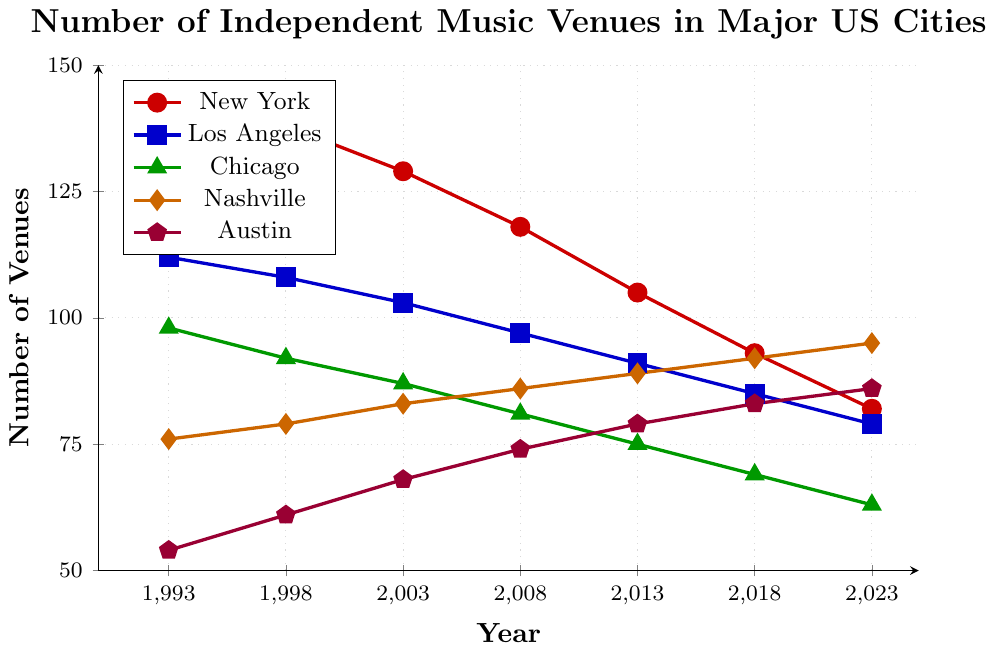How many independent music venues existed in New York in 1993? The figure shows the number of independent music venues for each year for New York. In 1993, New York had 145 venues.
Answer: 145 Which city had the highest number of independent music venues in 2018? The figure provides the number of venues for each city in 2018. Nashville had the highest number with 92 venues.
Answer: Nashville What is the trend of independent music venues in Chicago over the last 30 years? Observing the line representing Chicago on the figure, it shows a downward trend from 98 in 1993 to 63 in 2023.
Answer: Downward trend Between which consecutive years did Austin see the largest increase in the number of independent music venues? Comparing the differences year by year for Austin: 1993-1998: 7, 1998-2003: 7, 2003-2008: 6, 2008-2013: 5, 2013-2018: 4, 2018-2023: 3. The largest increase is between 1993 and 1998 with an increase of 7 venues.
Answer: 1993-1998 Which city had the smallest number of independent music venues in 1993? From the figure, Austin had 54 venues in 1993, which is the smallest among the given cities.
Answer: Austin By how much did the number of independent music venues in Los Angeles decrease from 1993 to 2023? The difference in the number of venues in Los Angeles between 1993 and 2023 is 112 - 79.
Answer: 33 Has there been any year when the number of independent music venues in Nashville was equal to that in Austin? Reviewing the figure, in none of the years do Nashville and Austin have the exact same number of venues.
Answer: No What is the overall percentage decline in the number of independent music venues in New York from 1993 to 2023? Calculating the percentage decrease: ((145 - 82) / 145) * 100 ≈ 43.45%.
Answer: 43.45% Compare the number of independent music venues in New York and Los Angeles in 2023 and determine the difference. In 2023, New York had 82 venues, and Los Angeles had 79 venues. The difference is 82 - 79.
Answer: 3 What is the cumulative decrease in the number of independent music venues for all the cities combined from 1993 to 2023? Calculate the decrease for each city and then sum it up: New York (145 - 82) + Los Angeles (112 - 79) + Chicago (98 - 63) + Nashville (76 - 95) + Austin (54 - 86). Total decrease is 63 + 33 + 35 + (-19) + (-32) = 80.
Answer: 80 